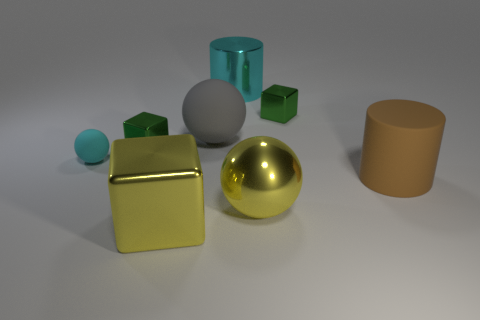Add 1 big blue metallic objects. How many objects exist? 9 Subtract all cylinders. How many objects are left? 6 Add 6 big brown matte cylinders. How many big brown matte cylinders are left? 7 Add 4 tiny cyan matte balls. How many tiny cyan matte balls exist? 5 Subtract 2 green cubes. How many objects are left? 6 Subtract all cyan rubber objects. Subtract all big metallic objects. How many objects are left? 4 